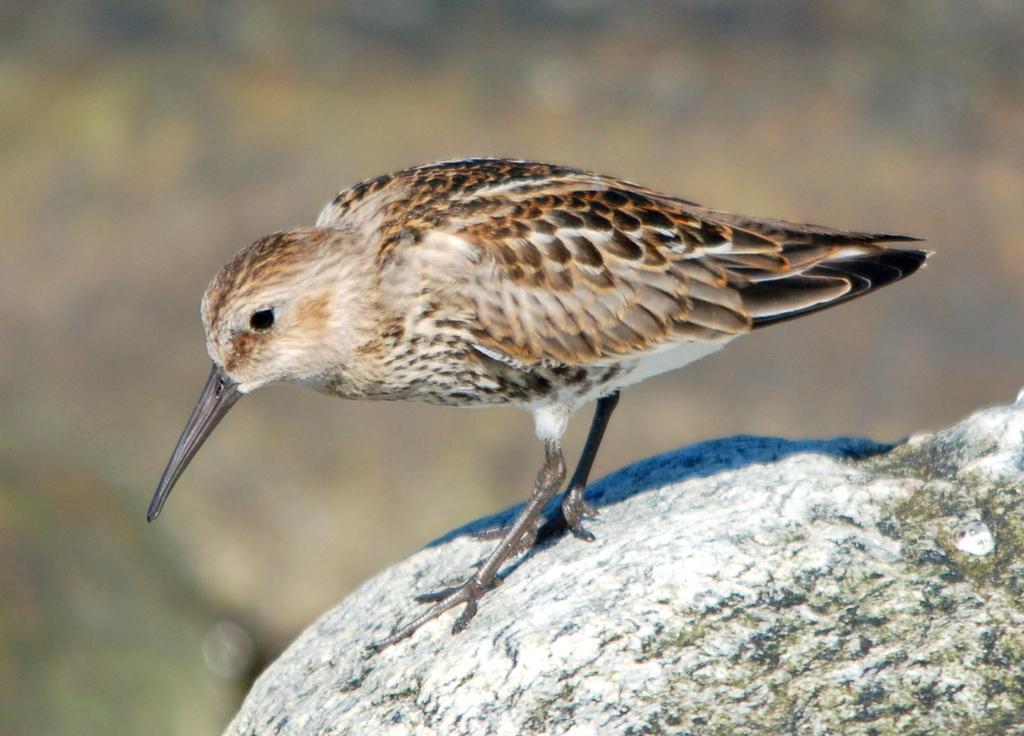Could you give a brief overview of what you see in this image? In this picture I can see a bird standing on the rock, and there is blur background. 